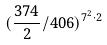<formula> <loc_0><loc_0><loc_500><loc_500>( \frac { 3 7 4 } { 2 } / 4 0 6 ) ^ { 7 ^ { 2 } \cdot 2 }</formula> 